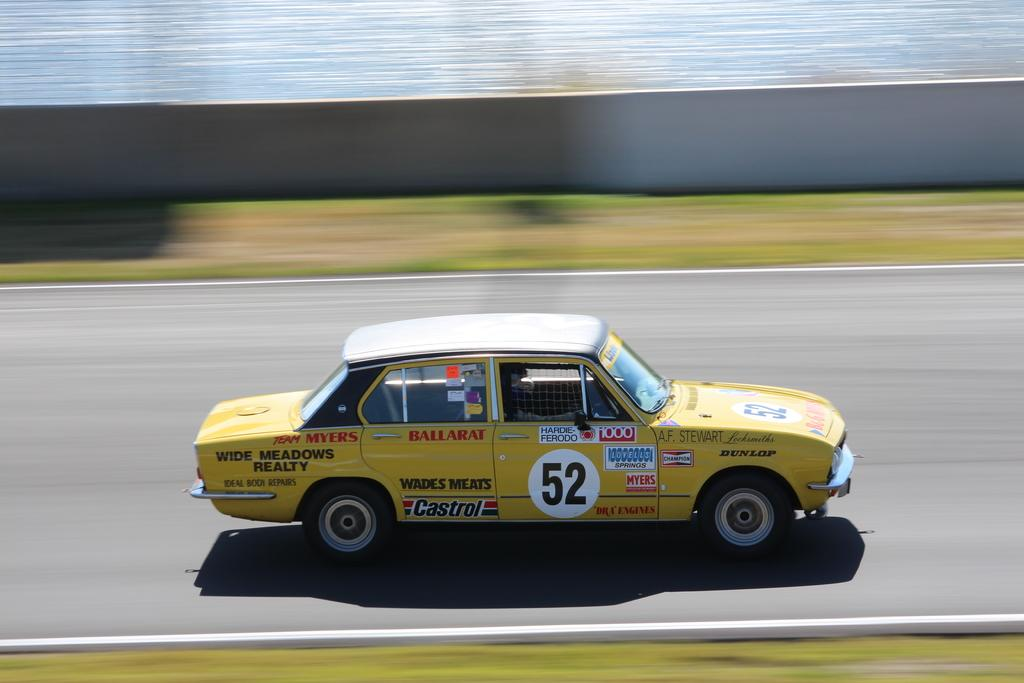What color is the car that is visible in the image? The car is yellow in the image. Where is the car located in the image? The car is on the road in the image. What additional details can be seen on the car? There are logos and names visible on the car. What type of cough medicine is advertised on the car in the image? There is no cough medicine advertised on the car in the image. What type of holiday destination is promoted on the car in the image? There is no holiday destination promoted on the car in the image. What type of fruit is being sold from the car in the image? There is no fruit being sold from the car in the image. 